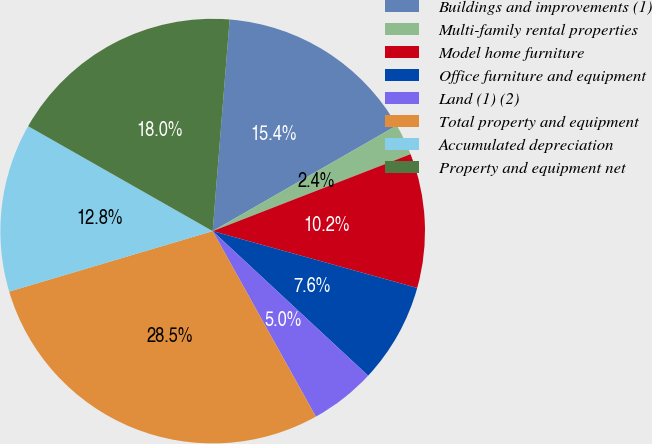<chart> <loc_0><loc_0><loc_500><loc_500><pie_chart><fcel>Buildings and improvements (1)<fcel>Multi-family rental properties<fcel>Model home furniture<fcel>Office furniture and equipment<fcel>Land (1) (2)<fcel>Total property and equipment<fcel>Accumulated depreciation<fcel>Property and equipment net<nl><fcel>15.44%<fcel>2.39%<fcel>10.22%<fcel>7.61%<fcel>5.0%<fcel>28.49%<fcel>12.83%<fcel>18.05%<nl></chart> 